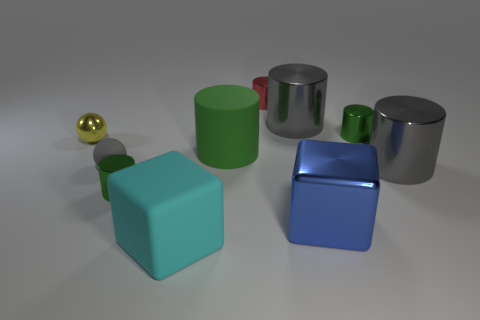Do the red thing and the gray matte sphere have the same size? yes 